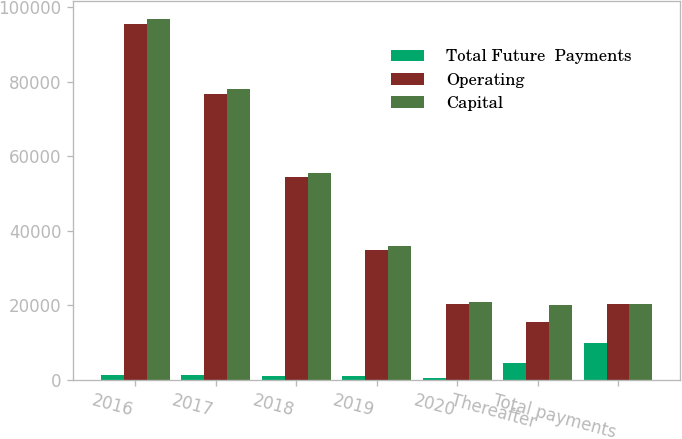<chart> <loc_0><loc_0><loc_500><loc_500><stacked_bar_chart><ecel><fcel>2016<fcel>2017<fcel>2018<fcel>2019<fcel>2020<fcel>Thereafter<fcel>Total payments<nl><fcel>Total Future  Payments<fcel>1385<fcel>1257<fcel>1139<fcel>972<fcel>555<fcel>4537<fcel>9845<nl><fcel>Operating<fcel>95407<fcel>76748<fcel>54306<fcel>34907<fcel>20263<fcel>15454<fcel>20263<nl><fcel>Capital<fcel>96792<fcel>78005<fcel>55445<fcel>35879<fcel>20818<fcel>19991<fcel>20263<nl></chart> 